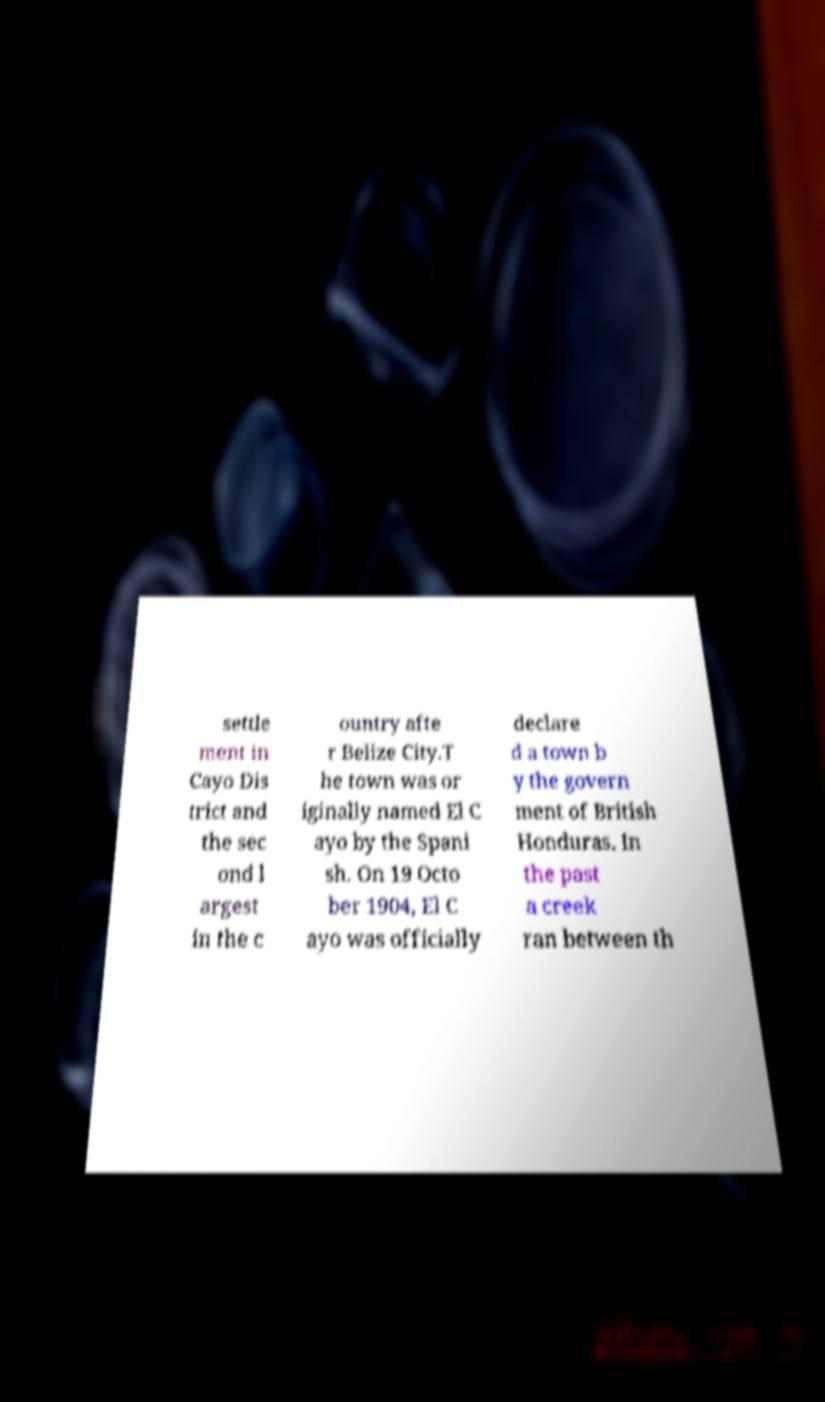For documentation purposes, I need the text within this image transcribed. Could you provide that? settle ment in Cayo Dis trict and the sec ond l argest in the c ountry afte r Belize City.T he town was or iginally named El C ayo by the Spani sh. On 19 Octo ber 1904, El C ayo was officially declare d a town b y the govern ment of British Honduras. In the past a creek ran between th 